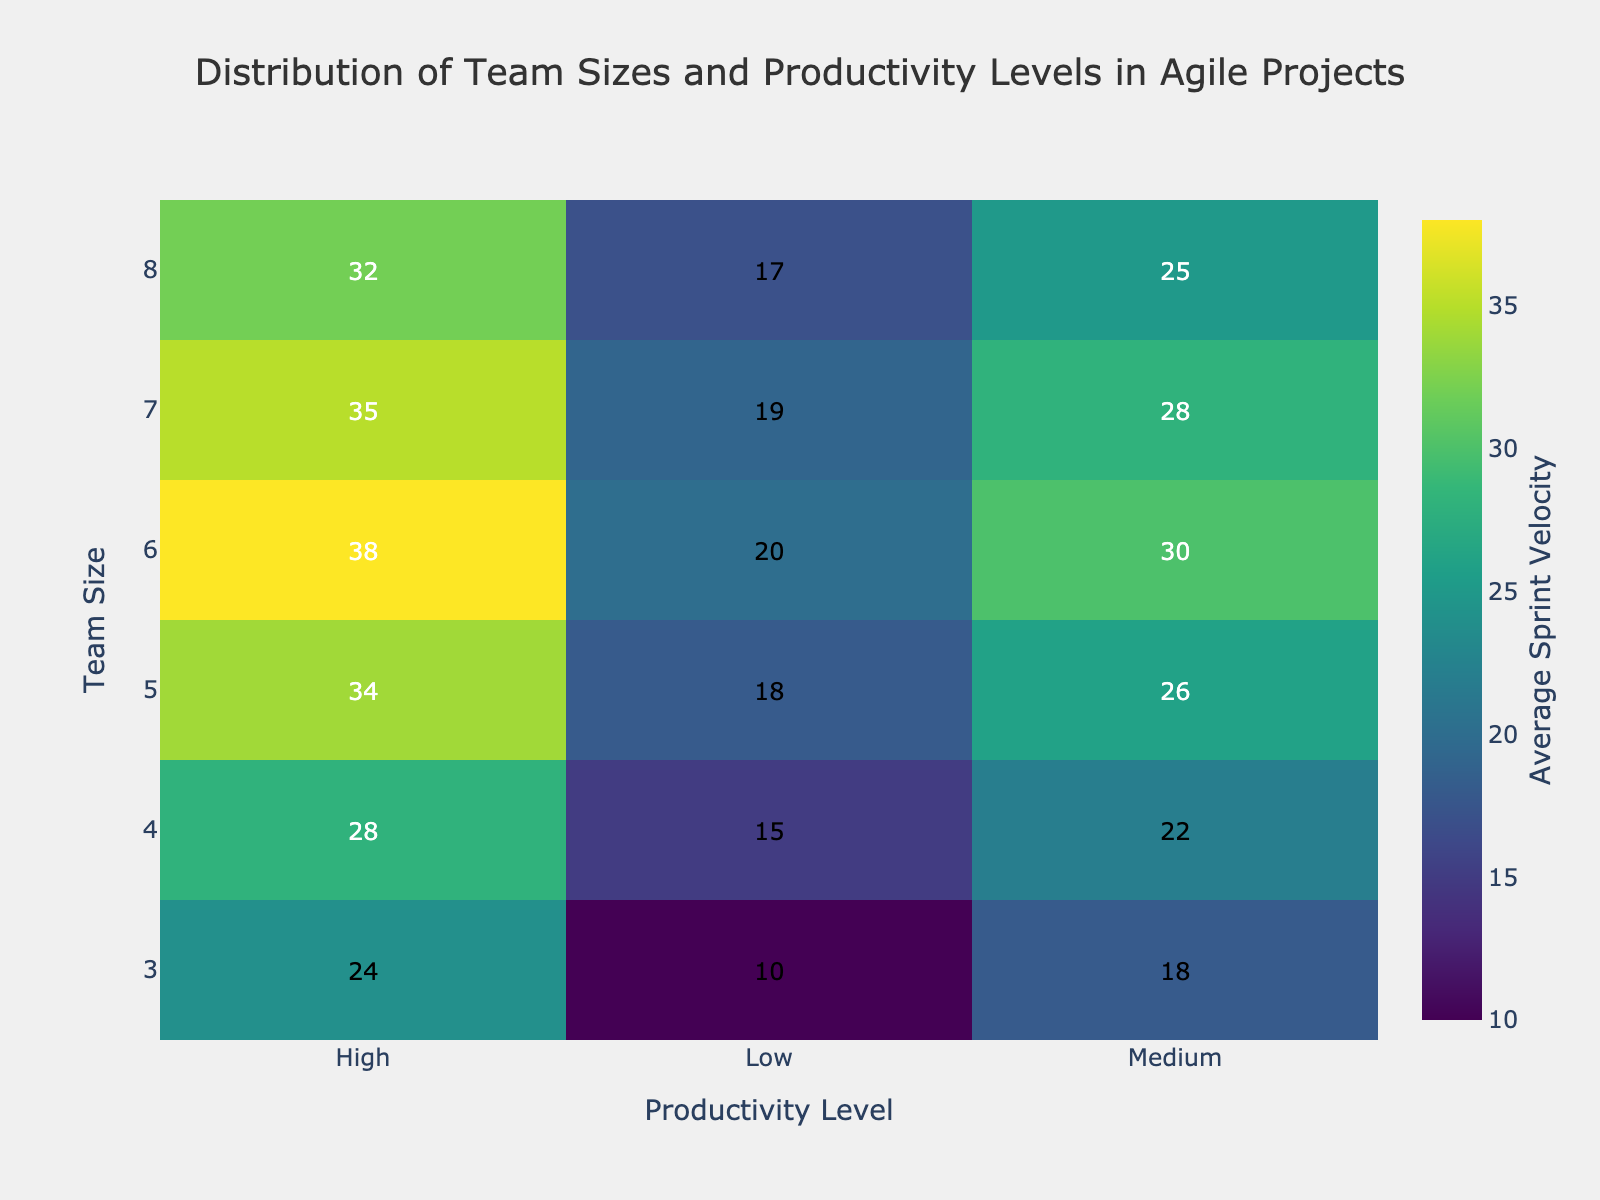What is the title of the heatmap? The title is located at the top of the heatmap and it clearly states the context of the data being visualized.
Answer: Distribution of Team Sizes and Productivity Levels in Agile Projects Which team size has the highest average sprint velocity at the high productivity level? Locate the "High" productivity level column and find the team size row with the highest value. The team with 6 members has the highest value of 38.
Answer: 6 How does the average sprint velocity for a team of 4 compare between the low and high productivity levels? Compare the values in the "Low" and "High" columns for the row corresponding to team size 4. For team size 4, the "Low" productivity level has a value of 15 and the "High" has a value of 28.
Answer: The high productivity level (28) is higher than the low productivity level (15) What is the average sprint velocity for teams of size 5? Locate the row for team size 5 and find the values for all productivity levels, then compute the average of these values: (18 + 26 + 34) / 3 = 26.
Answer: 26 Which productivity level shows the maximum difference in average sprint velocity between the smallest and largest team sizes? Calculate the difference in average sprint velocity between team sizes 3 and 8 for each productivity level: Low: (17-10)=7, Medium: (25-18)=7, High: (32-24)=8. Therefore, "High" shows the maximum difference of 8.
Answer: High What is the color scale of the heatmap based on? The color scale at the right side of the heatmap shows that the color variations correspond to different values of average sprint velocity, ranging from 10 to 38.
Answer: Average Sprint Velocity Which team size has the lowest average sprint velocity in the medium productivity level? Find the value for each team size in the "Medium" productivity level column and identify the smallest value. The team with 3 members has the lowest value of 18.
Answer: 3 Are there any team sizes where the average sprint velocity decreases as the productivity level goes from low to medium? Compare the values from "Low" to "Medium" for each team size. The values either increase or remain the same. There are no decreases.
Answer: No What is the most common color on the heatmap? Observe the color distribution across the entire heatmap. A mix of mid-range colors between the darkest (low velocity) and brightest (high velocity) seems most common around the "Medium" values.
Answer: Mid-range colors How much higher is the average sprint velocity for a team of 7 at the high productivity level compared to the medium productivity level? Subtract the average sprint velocity at the medium level (28) from that at the high level (35) for team size 7. 35 - 28 = 7.
Answer: 7 